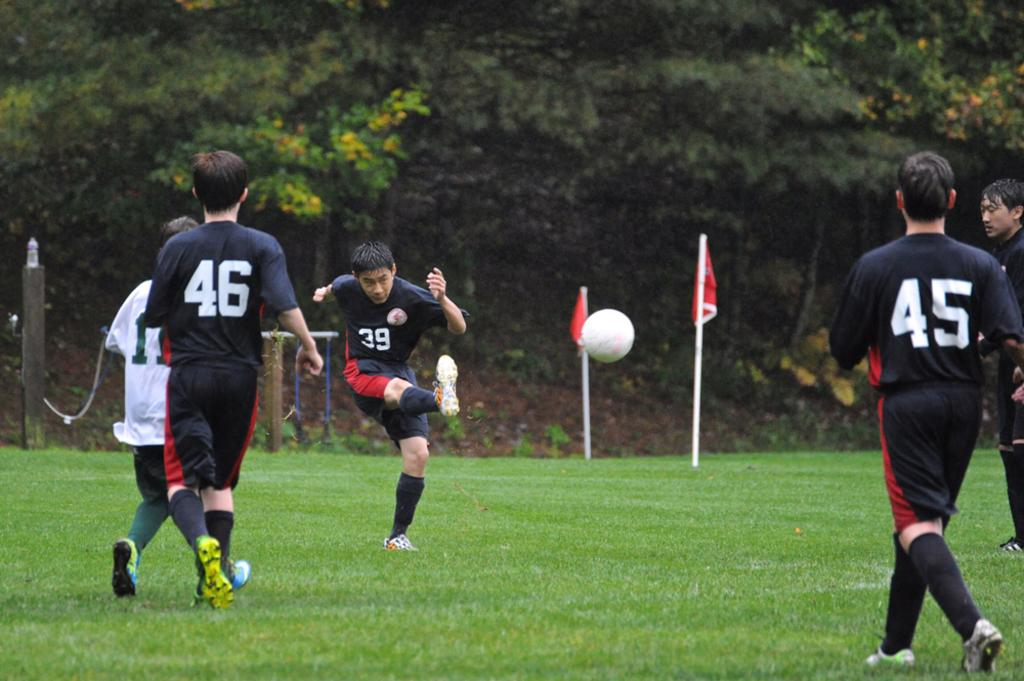What is happening on the ground in the image? There are players on the ground in the image. What can be seen flying or waving in the image? Flags are visible in the image. What type of structures are present in the image? There are wooden poles in the image. What natural elements can be seen in the image? Surrounding trees are present in the image. Where is the nest located in the image? There is no nest present in the image. Can you see a river flowing through the image? There is no river visible in the image. 